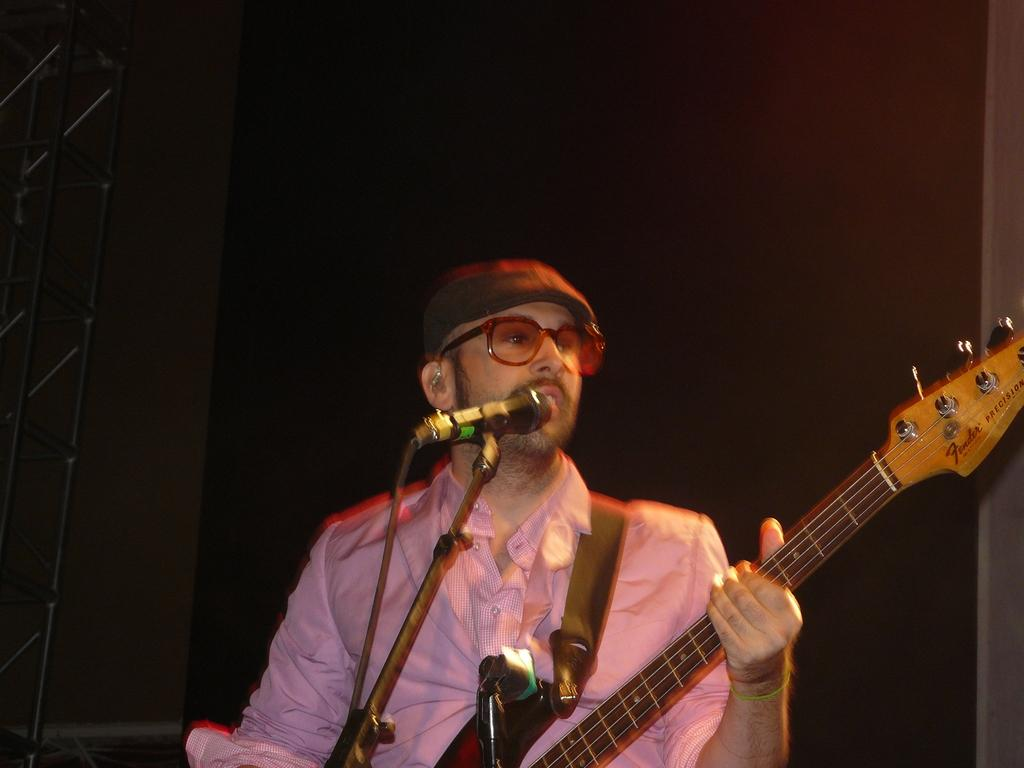What is the man in the image holding? The man is holding a guitar. Can you describe any other guitars in the image? Yes, there is another guitar in front of the man. How many geese are visible on the top of the guitars in the image? There are no geese visible on the top of the guitars in the image. What type of frogs can be seen hopping around the man in the image? There are no frogs present in the image. 